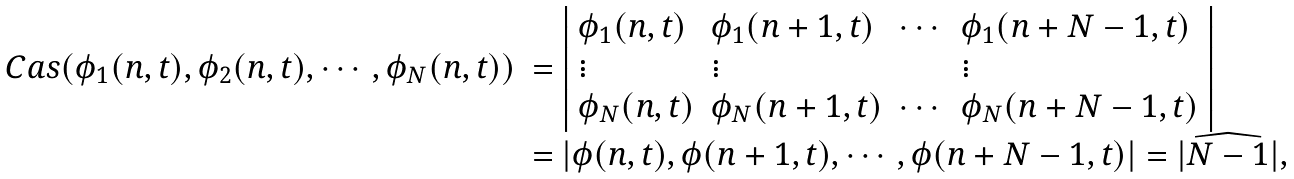Convert formula to latex. <formula><loc_0><loc_0><loc_500><loc_500>\begin{array} { r l } C a s ( \phi _ { 1 } ( n , t ) , \phi _ { 2 } ( n , t ) , \cdots , \phi _ { N } ( n , t ) ) & = \left | \begin{array} { l l l l } \phi _ { 1 } ( n , t ) & \phi _ { 1 } ( n + 1 , t ) & \cdots & \phi _ { 1 } ( n + N - 1 , t ) \\ \vdots & \vdots & & \vdots \\ \phi _ { N } ( n , t ) & \phi _ { N } ( n + 1 , t ) & \cdots & \phi _ { N } ( n + N - 1 , t ) \end{array} \right | \\ & = | \phi ( n , t ) , \phi ( n + 1 , t ) , \cdots , \phi ( n + N - 1 , t ) | = | \widehat { N - 1 } | , \end{array}</formula> 